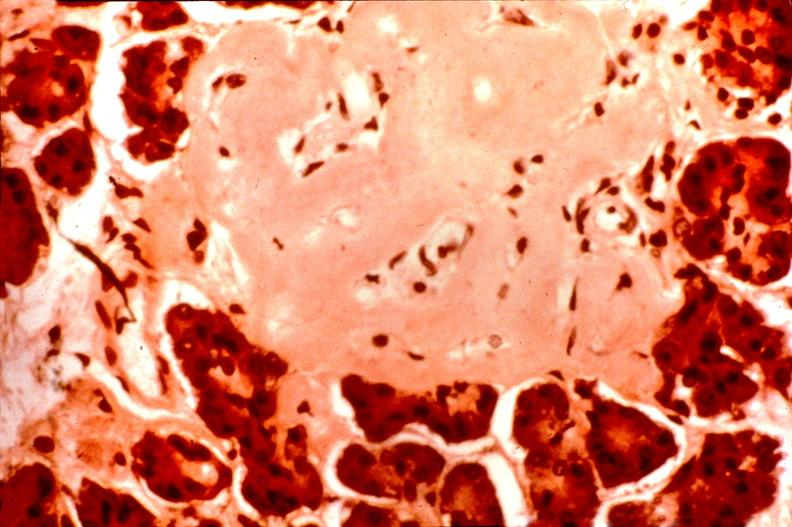what does this image show?
Answer the question using a single word or phrase. Pancrease 